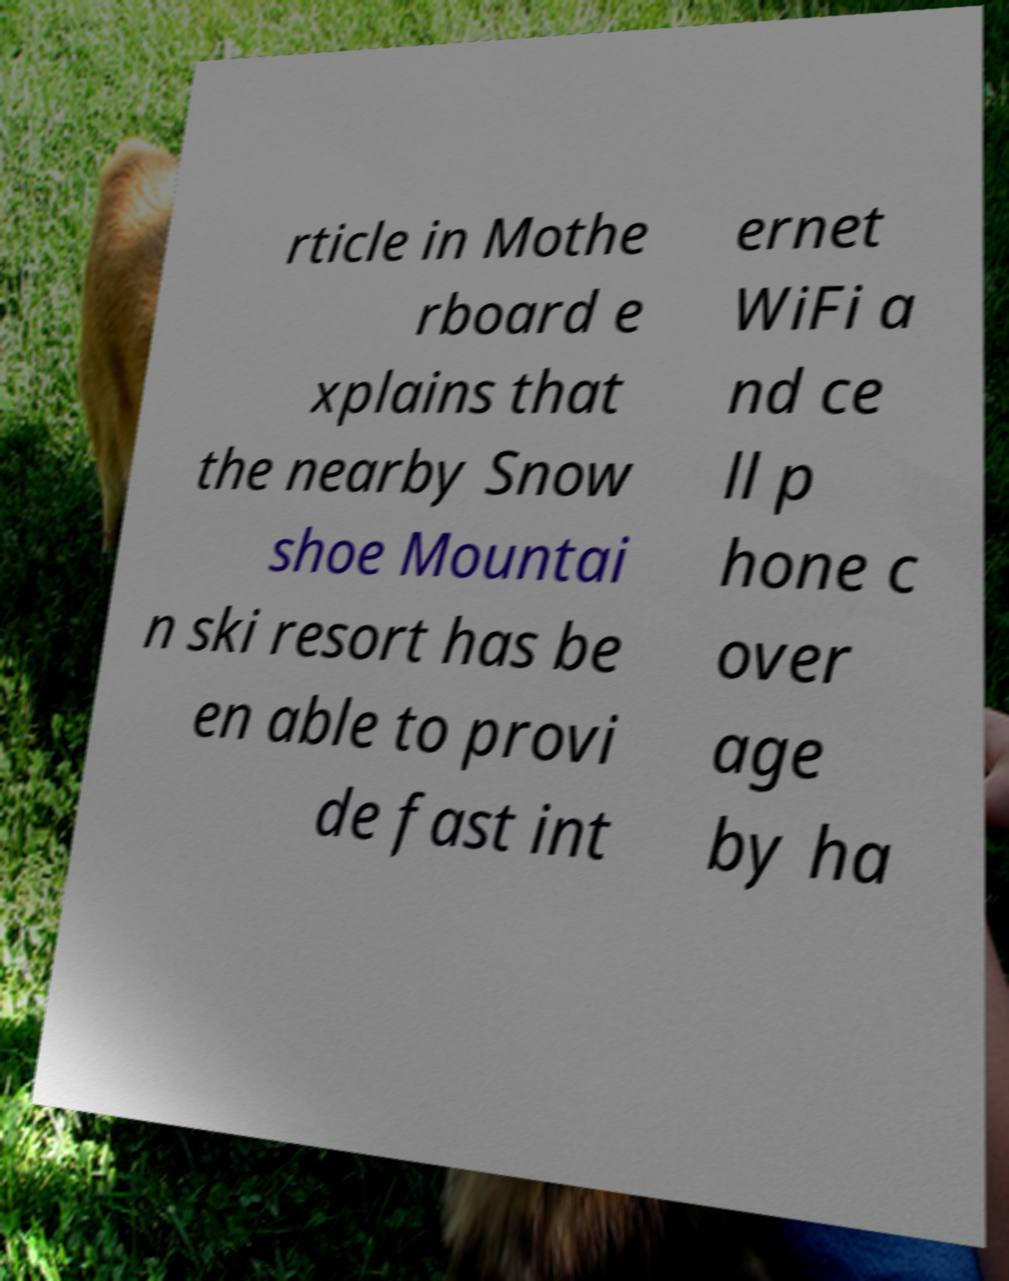Could you assist in decoding the text presented in this image and type it out clearly? rticle in Mothe rboard e xplains that the nearby Snow shoe Mountai n ski resort has be en able to provi de fast int ernet WiFi a nd ce ll p hone c over age by ha 